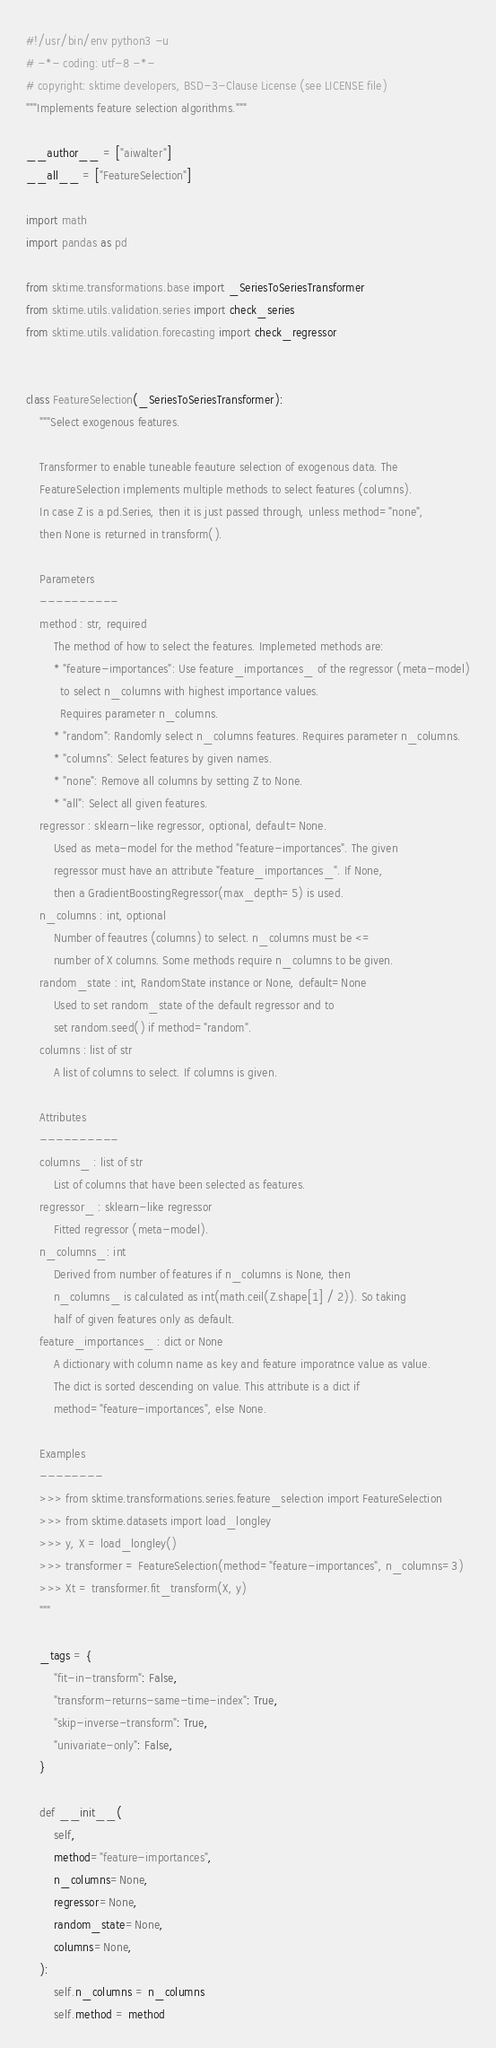<code> <loc_0><loc_0><loc_500><loc_500><_Python_>#!/usr/bin/env python3 -u
# -*- coding: utf-8 -*-
# copyright: sktime developers, BSD-3-Clause License (see LICENSE file)
"""Implements feature selection algorithms."""

__author__ = ["aiwalter"]
__all__ = ["FeatureSelection"]

import math
import pandas as pd

from sktime.transformations.base import _SeriesToSeriesTransformer
from sktime.utils.validation.series import check_series
from sktime.utils.validation.forecasting import check_regressor


class FeatureSelection(_SeriesToSeriesTransformer):
    """Select exogenous features.

    Transformer to enable tuneable feauture selection of exogenous data. The
    FeatureSelection implements multiple methods to select features (columns).
    In case Z is a pd.Series, then it is just passed through, unless method="none",
    then None is returned in transform().

    Parameters
    ----------
    method : str, required
        The method of how to select the features. Implemeted methods are:
        * "feature-importances": Use feature_importances_ of the regressor (meta-model)
          to select n_columns with highest importance values.
          Requires parameter n_columns.
        * "random": Randomly select n_columns features. Requires parameter n_columns.
        * "columns": Select features by given names.
        * "none": Remove all columns by setting Z to None.
        * "all": Select all given features.
    regressor : sklearn-like regressor, optional, default=None.
        Used as meta-model for the method "feature-importances". The given
        regressor must have an attribute "feature_importances_". If None,
        then a GradientBoostingRegressor(max_depth=5) is used.
    n_columns : int, optional
        Number of feautres (columns) to select. n_columns must be <=
        number of X columns. Some methods require n_columns to be given.
    random_state : int, RandomState instance or None, default=None
        Used to set random_state of the default regressor and to
        set random.seed() if method="random".
    columns : list of str
        A list of columns to select. If columns is given.

    Attributes
    ----------
    columns_ : list of str
        List of columns that have been selected as features.
    regressor_ : sklearn-like regressor
        Fitted regressor (meta-model).
    n_columns_: int
        Derived from number of features if n_columns is None, then
        n_columns_ is calculated as int(math.ceil(Z.shape[1] / 2)). So taking
        half of given features only as default.
    feature_importances_ : dict or None
        A dictionary with column name as key and feature imporatnce value as value.
        The dict is sorted descending on value. This attribute is a dict if
        method="feature-importances", else None.

    Examples
    --------
    >>> from sktime.transformations.series.feature_selection import FeatureSelection
    >>> from sktime.datasets import load_longley
    >>> y, X = load_longley()
    >>> transformer = FeatureSelection(method="feature-importances", n_columns=3)
    >>> Xt = transformer.fit_transform(X, y)
    """

    _tags = {
        "fit-in-transform": False,
        "transform-returns-same-time-index": True,
        "skip-inverse-transform": True,
        "univariate-only": False,
    }

    def __init__(
        self,
        method="feature-importances",
        n_columns=None,
        regressor=None,
        random_state=None,
        columns=None,
    ):
        self.n_columns = n_columns
        self.method = method</code> 